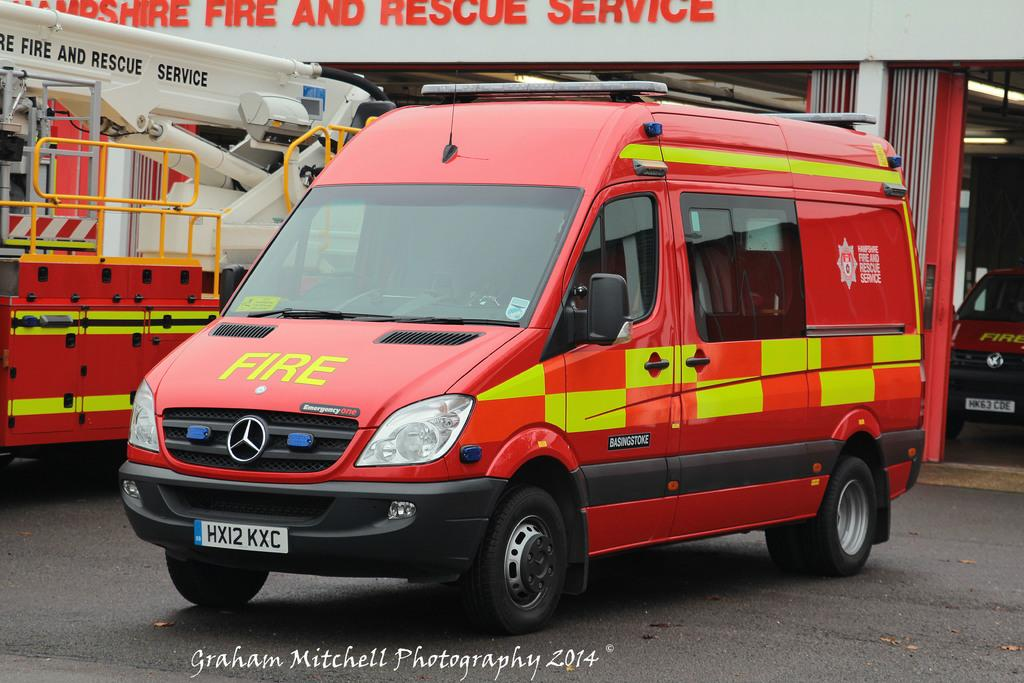Provide a one-sentence caption for the provided image. a red van with the words FIRE on the hood. 